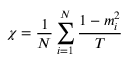Convert formula to latex. <formula><loc_0><loc_0><loc_500><loc_500>\chi = \frac { 1 } { N } \sum _ { i = 1 } ^ { N } { \frac { { 1 - m _ { i } ^ { 2 } } } { T } }</formula> 